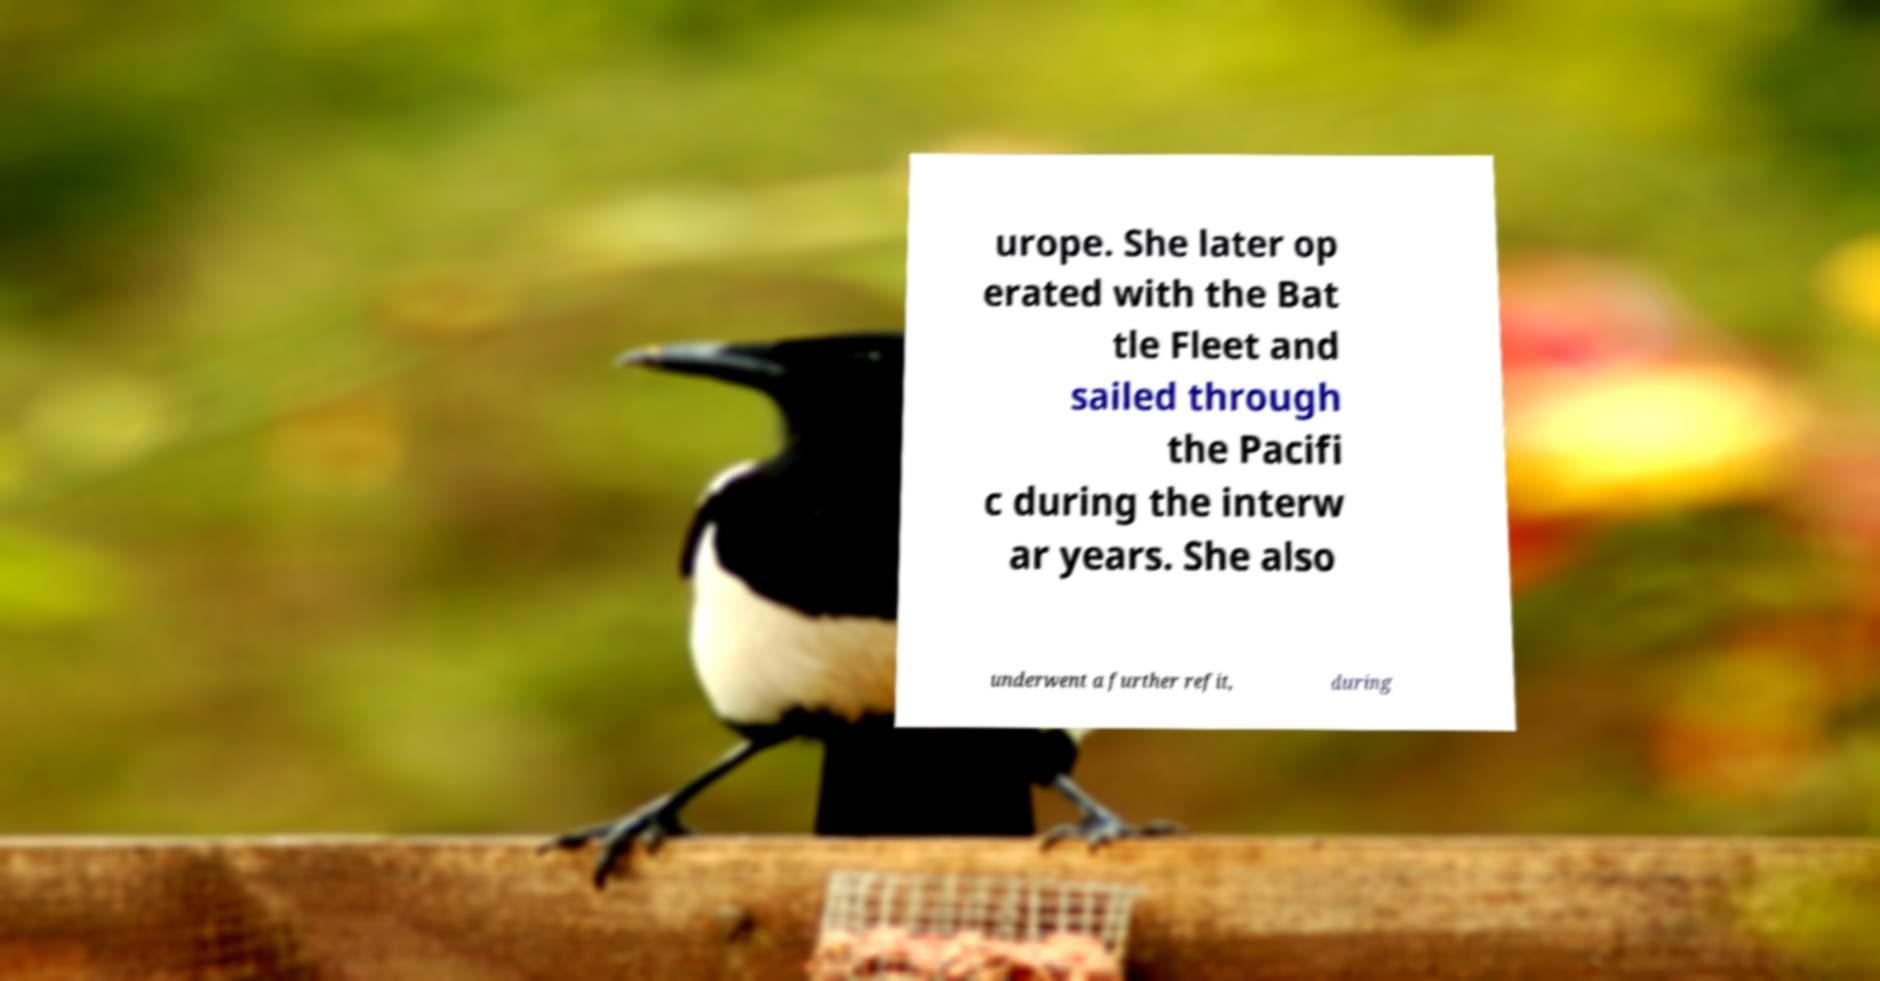Please read and relay the text visible in this image. What does it say? urope. She later op erated with the Bat tle Fleet and sailed through the Pacifi c during the interw ar years. She also underwent a further refit, during 